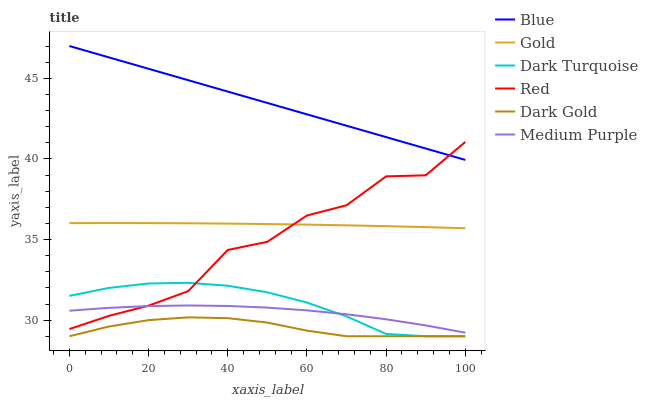Does Dark Gold have the minimum area under the curve?
Answer yes or no. Yes. Does Blue have the maximum area under the curve?
Answer yes or no. Yes. Does Gold have the minimum area under the curve?
Answer yes or no. No. Does Gold have the maximum area under the curve?
Answer yes or no. No. Is Blue the smoothest?
Answer yes or no. Yes. Is Red the roughest?
Answer yes or no. Yes. Is Gold the smoothest?
Answer yes or no. No. Is Gold the roughest?
Answer yes or no. No. Does Dark Gold have the lowest value?
Answer yes or no. Yes. Does Gold have the lowest value?
Answer yes or no. No. Does Blue have the highest value?
Answer yes or no. Yes. Does Gold have the highest value?
Answer yes or no. No. Is Dark Turquoise less than Blue?
Answer yes or no. Yes. Is Gold greater than Dark Turquoise?
Answer yes or no. Yes. Does Red intersect Blue?
Answer yes or no. Yes. Is Red less than Blue?
Answer yes or no. No. Is Red greater than Blue?
Answer yes or no. No. Does Dark Turquoise intersect Blue?
Answer yes or no. No. 